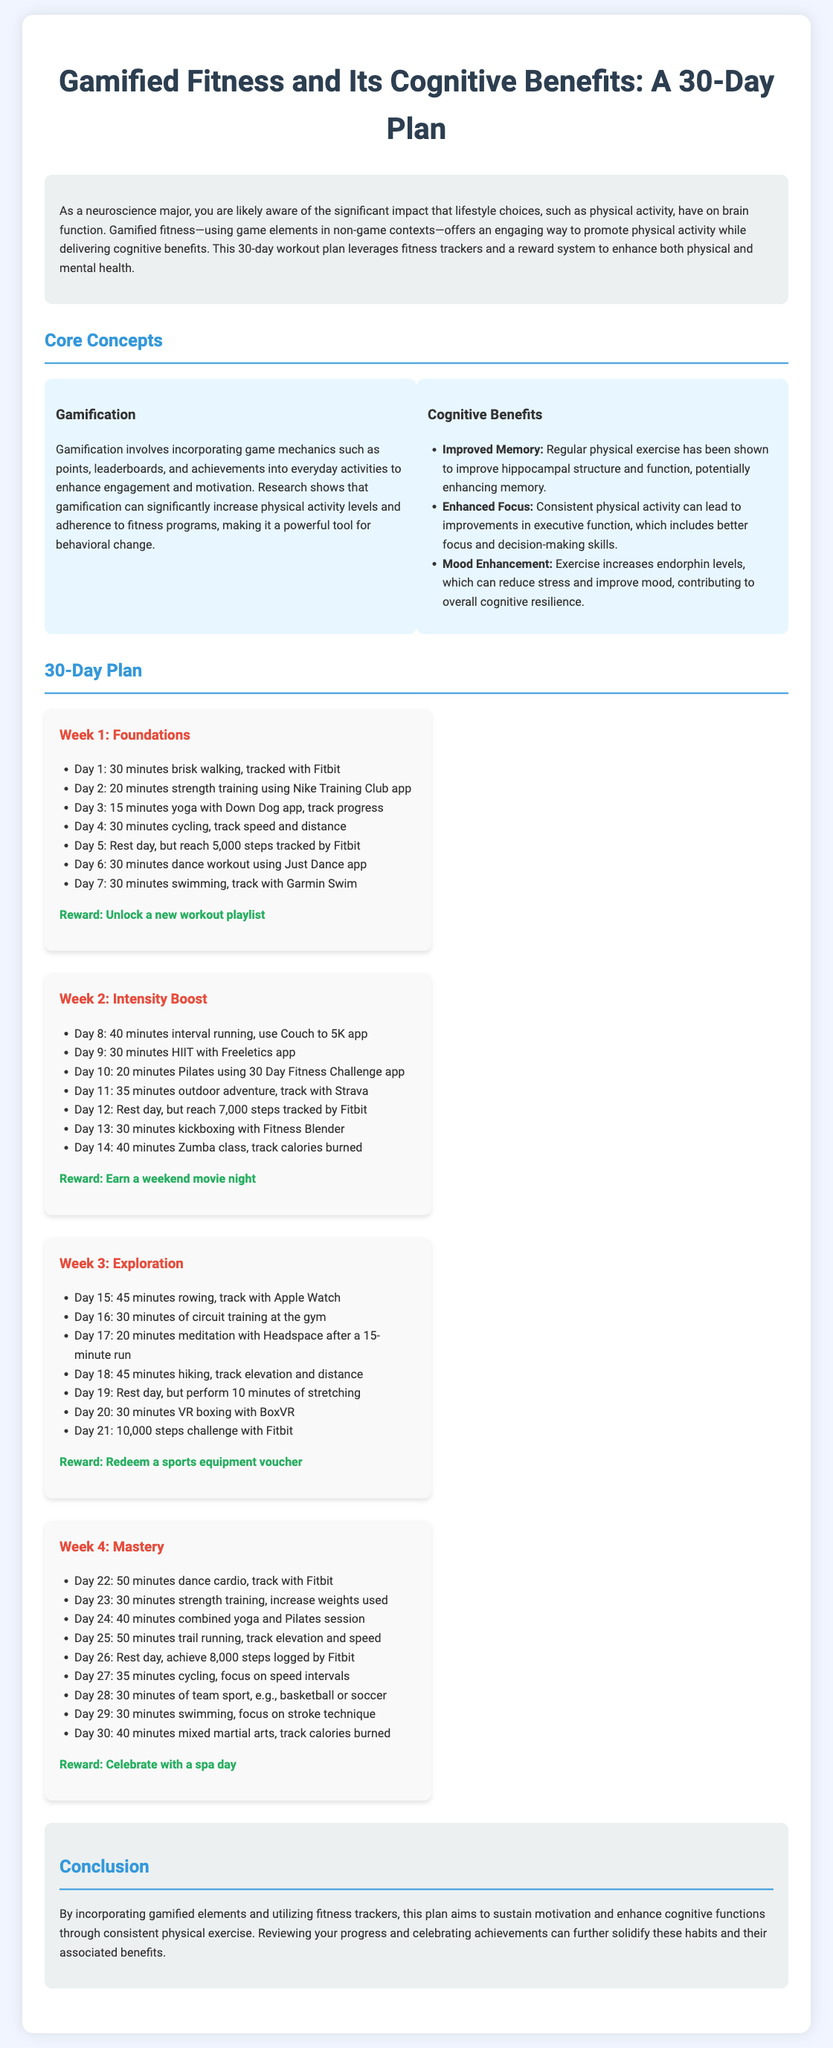what is the title of the document? The title is explicitly stated at the beginning of the document, which is "Gamified Fitness and Its Cognitive Benefits: A 30-Day Plan."
Answer: Gamified Fitness and Its Cognitive Benefits: A 30-Day Plan how many weeks are outlined in the plan? The plan is divided into four distinct sections labeled as weeks, indicating the number of weeks in the plan.
Answer: 4 what type of activity is recommended on Day 10? Day 10 features a specific type of exercise stated directly in the plan, which is Pilates.
Answer: Pilates which app is suggested for yoga? The document mentions a specific application designed for yoga, indicating which app to use.
Answer: Down Dog what reward do participants earn after Week 2? The reward for completing Week 2 is noted, providing insight into the incentive structure of the plan.
Answer: Earn a weekend movie night describe one cognitive benefit of exercise mentioned in the document. The document lists several cognitive benefits under the "Cognitive Benefits" section, highlighting specific improvements gained from exercise.
Answer: Improved Memory what is the first activity listed for Week 1? The first activity for Week 1 is clearly described in the weekly breakdown, providing a straightforward initial exercise.
Answer: 30 minutes brisk walking what is the target step count for the rest day in Week 1? The document specifies the number of steps that should be reached on the rest day, indicating a structured approach to activity.
Answer: 5,000 steps 